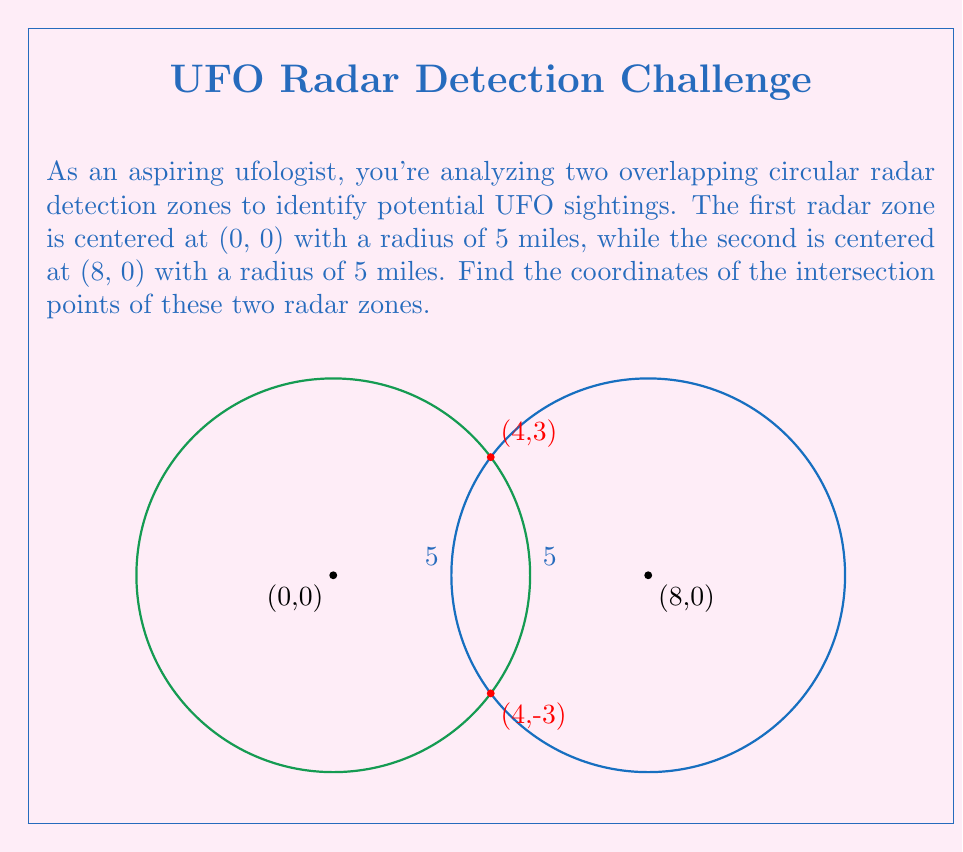Solve this math problem. Let's approach this step-by-step:

1) The equations of the two circles are:

   Circle 1: $x^2 + y^2 = 25$
   Circle 2: $(x-8)^2 + y^2 = 25$

2) To find the intersection points, we need to solve these equations simultaneously.

3) Subtracting the first equation from the second:

   $(x-8)^2 + y^2 = x^2 + y^2$
   $x^2 - 16x + 64 = x^2$
   $-16x + 64 = 0$
   $-16x = -64$
   $x = 4$

4) Now that we know the x-coordinate of the intersection points, we can substitute this back into either of the original equations. Let's use the first one:

   $4^2 + y^2 = 25$
   $16 + y^2 = 25$
   $y^2 = 9$
   $y = \pm 3$

5) Therefore, the intersection points are (4, 3) and (4, -3).

6) We can verify this by substituting these points into both original equations:

   For (4, 3): $4^2 + 3^2 = 25$ and $(4-8)^2 + 3^2 = 25$
   For (4, -3): $4^2 + (-3)^2 = 25$ and $(4-8)^2 + (-3)^2 = 25$

   Both points satisfy both equations.
Answer: (4, 3) and (4, -3) 